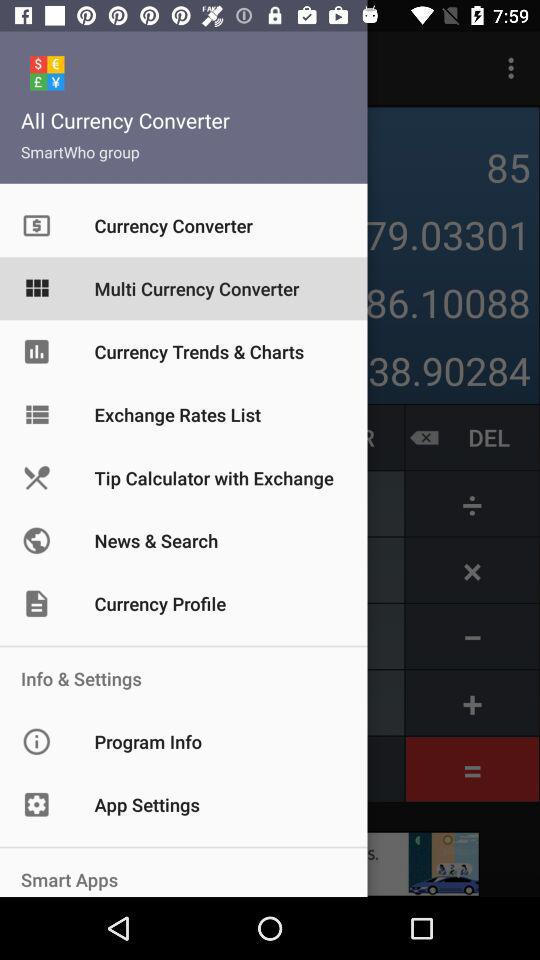What is the name of the application? The name of the application is "All Currency Converter". 